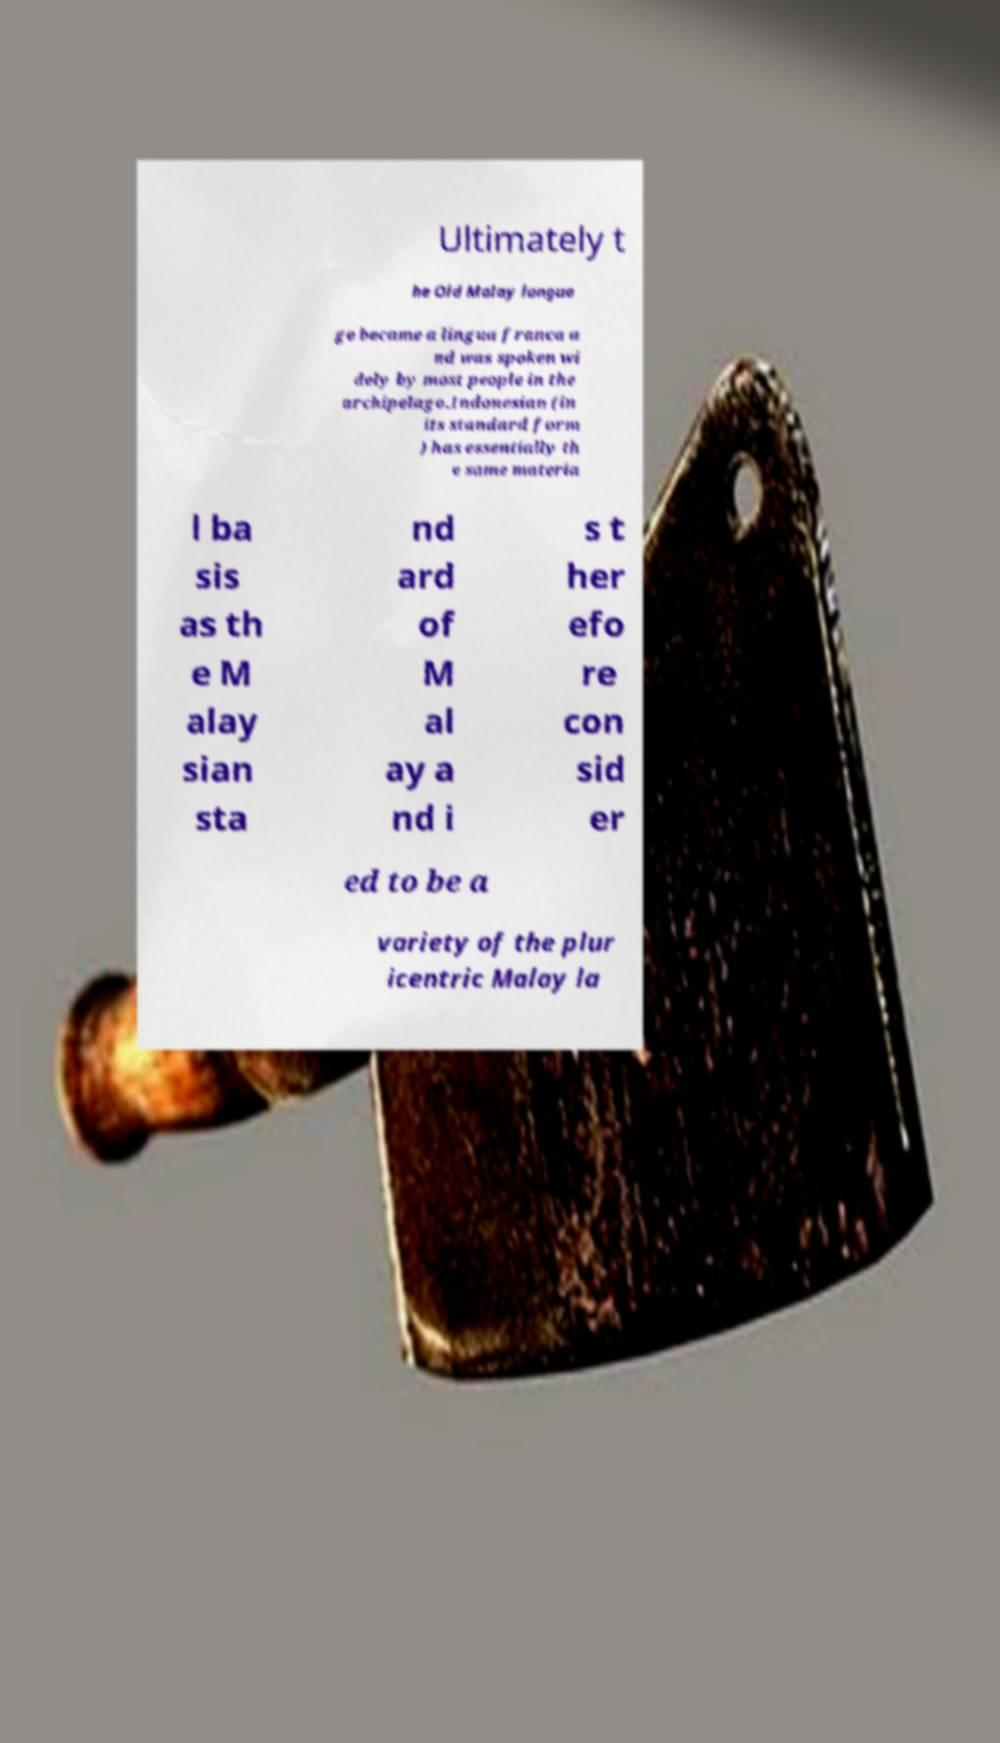For documentation purposes, I need the text within this image transcribed. Could you provide that? Ultimately t he Old Malay langua ge became a lingua franca a nd was spoken wi dely by most people in the archipelago.Indonesian (in its standard form ) has essentially th e same materia l ba sis as th e M alay sian sta nd ard of M al ay a nd i s t her efo re con sid er ed to be a variety of the plur icentric Malay la 